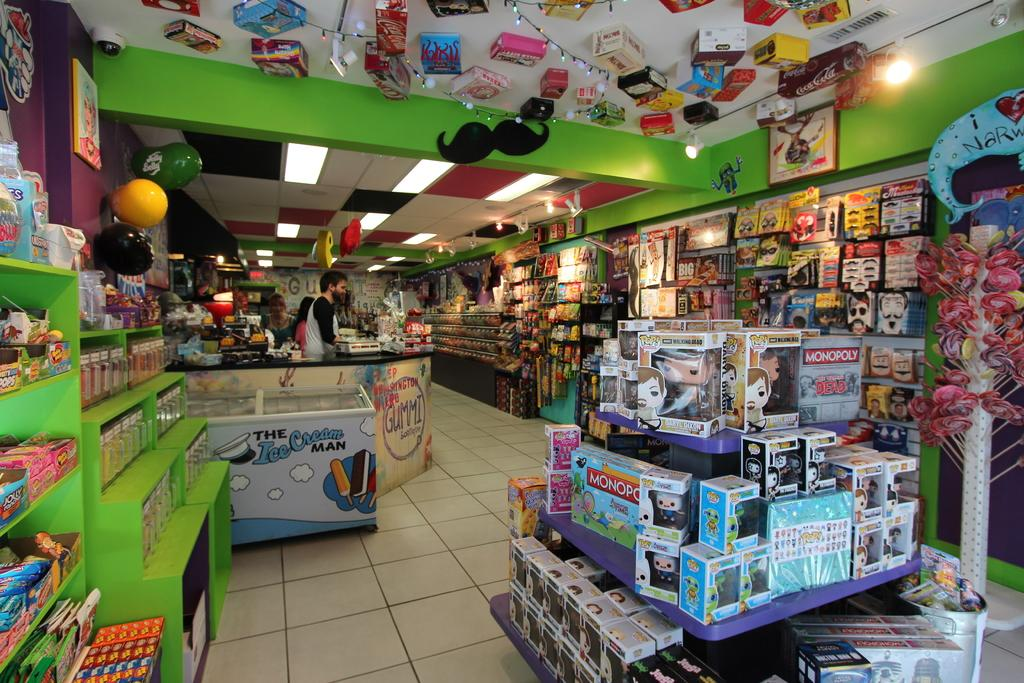<image>
Create a compact narrative representing the image presented. An inside of a toy store with shelves of toys and a display in the front with various toys including a Monopoly board game. 